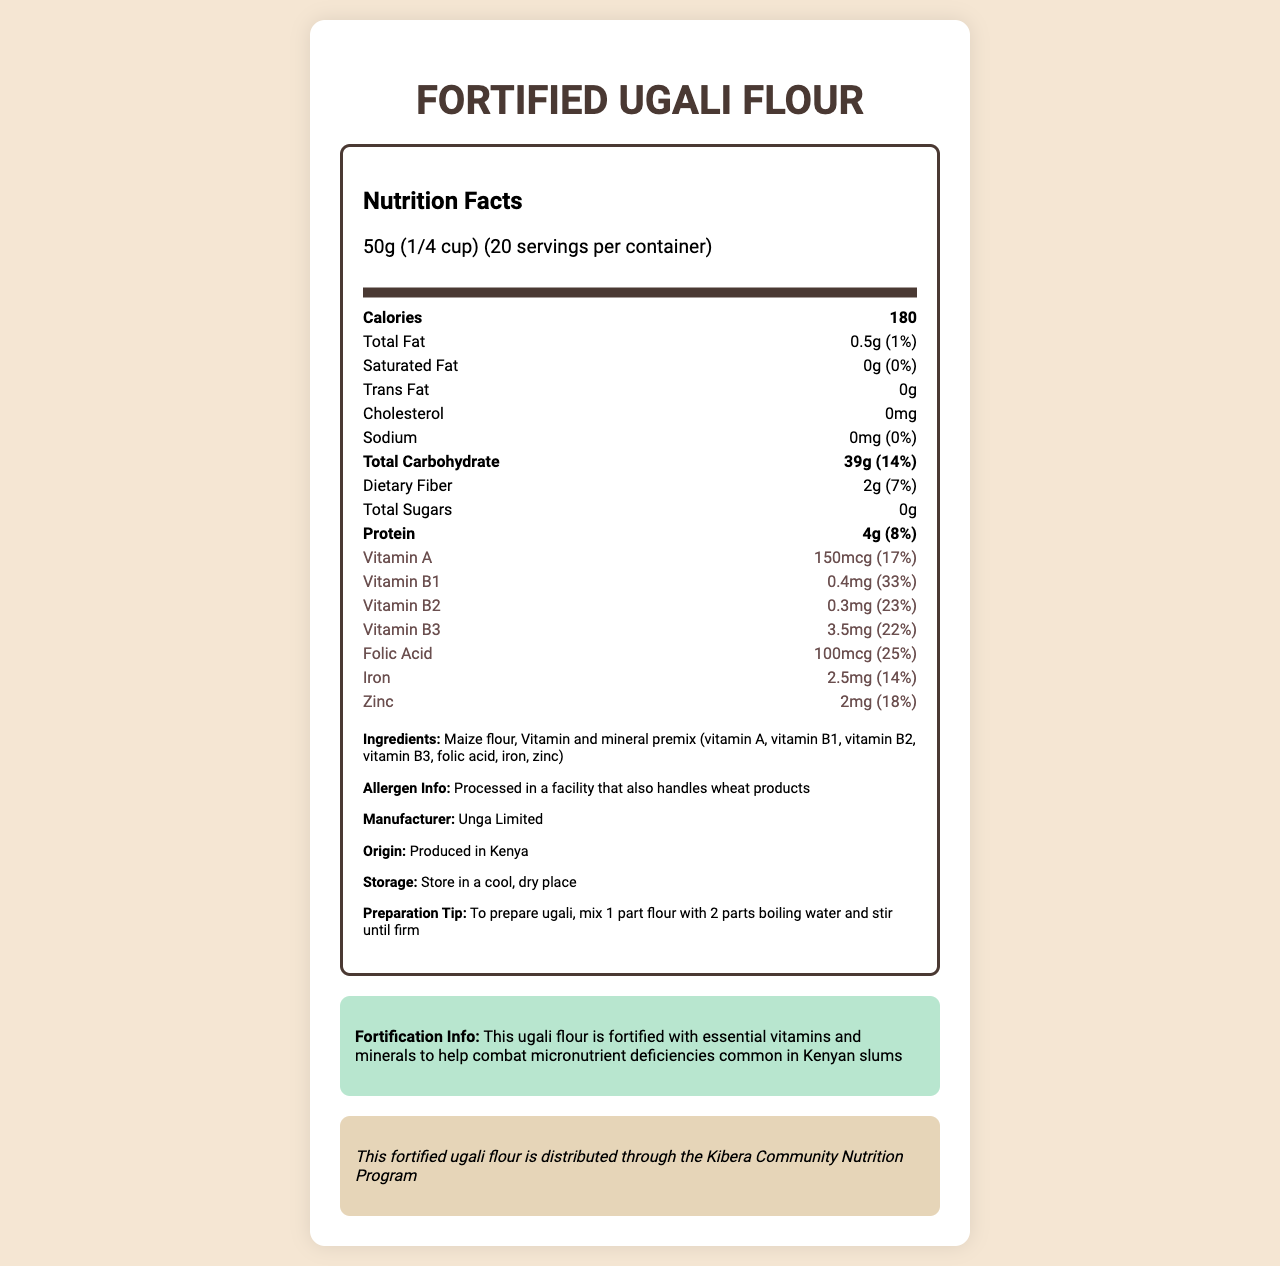what is the name of the product? The document title and heading clearly state the name of the product as "Fortified Ugali Flour".
Answer: Fortified Ugali Flour how many calories are in each serving? The document lists the calorie content for a single serving as 180.
Answer: 180 how much iron is in one serving of the flour? The document provides the amount of iron in one serving as 2.5mg.
Answer: 2.5mg what is the serving size for this product? The serving size is given as 50g, which is equivalent to 1/4 cup.
Answer: 50g (1/4 cup) what is the daily value percentage of Vitamin B1? The document lists Vitamin B1 (thiamine) as having a daily value of 33%.
Answer: 33% Which of the following vitamins has the highest daily value percentage in the flour? A. Vitamin A B. Vitamin B1 C. Vitamin B3 D. Folic Acid Vitamin B1 has a daily value percentage of 33%, which is higher compared to Vitamin A (17%), Vitamin B3 (22%), and Folic Acid (25%).
Answer: B. Vitamin B1 Which ingredient is not listed in the fortified vitamin and mineral premix? 1. Vitamin A 2. Vitamin C 3. Iron 4. Zinc The document lists Vitamin A, Vitamin B1, Vitamin B2, Vitamin B3, folic acid, iron, and zinc in the premix, but does not mention Vitamin C.
Answer: 2. Vitamin C is this product produced in Kenya? The origin of the product is stated as "Produced in Kenya".
Answer: Yes summarize the purpose and nutritional benefits of the fortified ugali flour The fortified ugali flour aims to combat micronutrient deficiencies. It contains essential nutrients like Vitamin A, B1, B2, B3, folic acid, iron, and zinc and is produced in Kenya by Unga Limited. The document mentions its distribution via the Kibera Community Nutrition Program, along with storage and preparation tips.
Answer: The document emphasizes that the fortified ugali flour is enriched with essential vitamins and minerals to address micronutrient deficiencies common in Kenyan slums. It contains significant amounts of Vitamin A, B1, B2, B3, folic acid, iron, and zinc. The product is produced in Kenya by Unga Limited, with specific instructions for storage and preparation included. It is also distributed through the Kibera Community Nutrition Program. What is the facility allergy information mentioned for this flour? The allergen information is given as being processed in a facility that also handles wheat products.
Answer: Processed in a facility that also handles wheat products how many grams of dietary fiber are there per serving? The document states that each serving contains 2g of dietary fiber.
Answer: 2g does this product contain any trans fat? The document specifies that the product contains 0g of trans fat.
Answer: No who is the manufacturer of this fortified flour? The manufacturer's name is given as Unga Limited.
Answer: Unga Limited how many servings are contained in one package? The document indicates that there are 20 servings per container.
Answer: 20 why is the flour fortified with vitamins and minerals? The document explains that the fortification is intended to address micronutrient deficiencies prevalent in Kenyan slums.
Answer: To help combat micronutrient deficiencies common in Kenyan slums what are the storage instructions for this product? The document provides storage instructions to keep the product in a cool, dry place.
Answer: Store in a cool, dry place how much protein does one serving provide? The document lists the protein content as 4g per serving.
Answer: 4g how many micrograms of folic acid does one serving have? The amount of folic acid per serving is stated as 100mcg.
Answer: 100mcg can the vitamin B2 daily value percentage be confirmed from the document? The document clearly states that the daily value percentage for Vitamin B2 is 23%.
Answer: Yes What is the method of preparation for ugali according to the document? The preparation tip provided in the document instructs to mix 1 part flour with 2 parts boiling water and stir until firm.
Answer: Mix 1 part flour with 2 parts boiling water and stir until firm How is the flour distributed in the community? The document mentions that the fortified ugali flour is distributed through the Kibera Community Nutrition Program.
Answer: Through the Kibera Community Nutrition Program What other product does the facility process besides this flour? The allergen information states that the facility also handles wheat products.
Answer: Wheat products Can the price of the product be determined from the document? The document does not provide any information regarding the price of the product.
Answer: Not enough information 